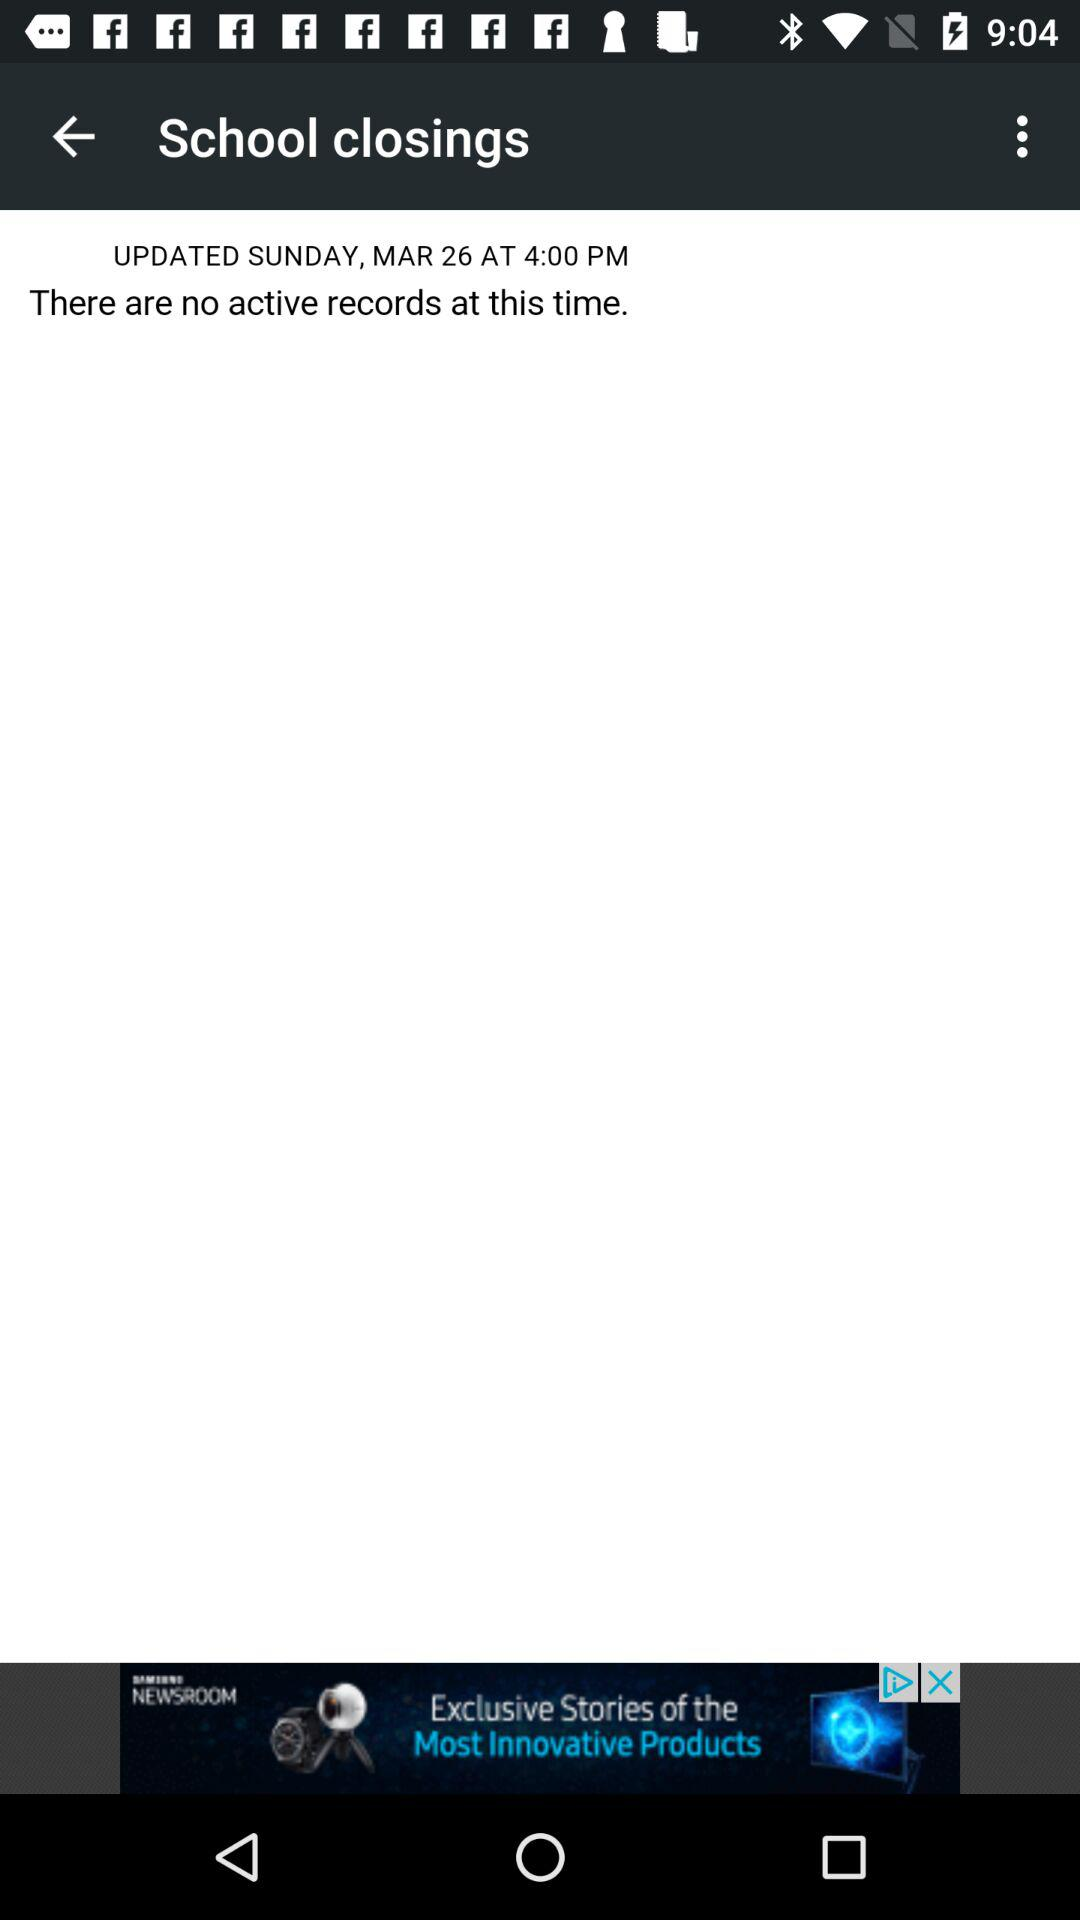How many records are currently active? There are no currently active records. 